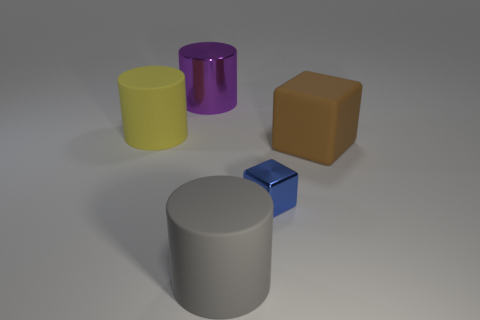Are there any other things that have the same size as the blue thing?
Your answer should be very brief. No. There is a object to the left of the large purple metallic thing; is it the same shape as the tiny blue shiny object that is left of the matte cube?
Offer a very short reply. No. There is a large rubber thing that is both left of the rubber cube and in front of the large yellow matte cylinder; what color is it?
Provide a succinct answer. Gray. How big is the thing that is to the right of the big gray matte cylinder and to the left of the big rubber block?
Make the answer very short. Small. What is the size of the metal thing that is in front of the big matte cylinder that is behind the big rubber thing in front of the small metal thing?
Your response must be concise. Small. Are there any matte cylinders to the left of the brown thing?
Your answer should be compact. Yes. Is the size of the purple thing the same as the matte cylinder behind the large gray thing?
Make the answer very short. Yes. What number of other objects are there of the same material as the big purple object?
Your response must be concise. 1. There is a object that is left of the large block and to the right of the gray cylinder; what shape is it?
Provide a succinct answer. Cube. Is the size of the matte object that is to the right of the big gray object the same as the rubber cylinder that is on the left side of the large gray rubber cylinder?
Ensure brevity in your answer.  Yes. 